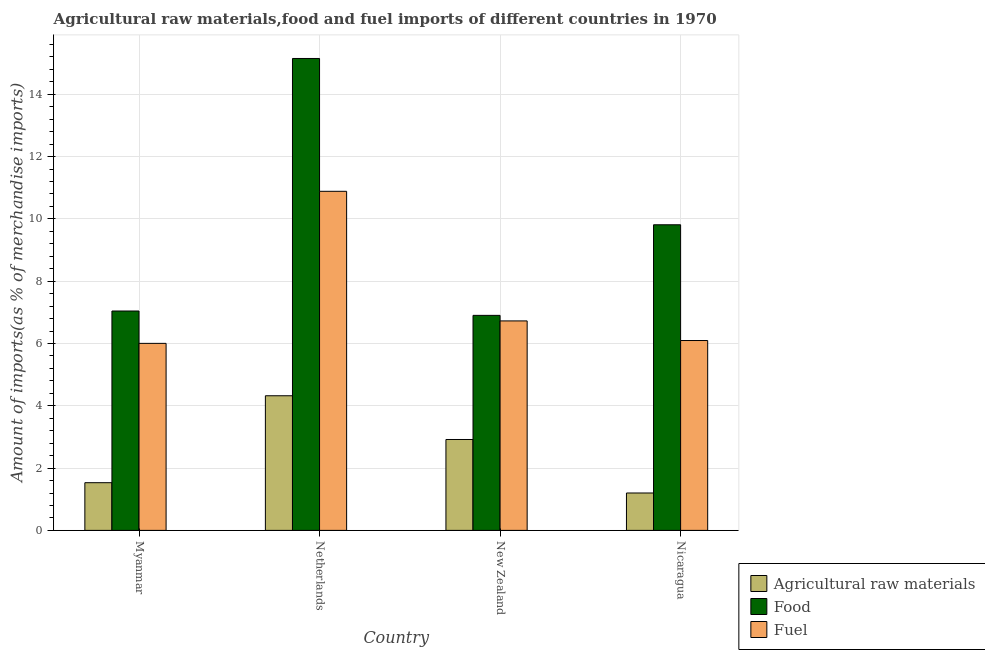How many different coloured bars are there?
Your answer should be compact. 3. How many groups of bars are there?
Offer a terse response. 4. Are the number of bars per tick equal to the number of legend labels?
Your answer should be very brief. Yes. How many bars are there on the 4th tick from the right?
Offer a very short reply. 3. What is the label of the 2nd group of bars from the left?
Offer a very short reply. Netherlands. In how many cases, is the number of bars for a given country not equal to the number of legend labels?
Keep it short and to the point. 0. What is the percentage of raw materials imports in New Zealand?
Provide a succinct answer. 2.92. Across all countries, what is the maximum percentage of raw materials imports?
Offer a terse response. 4.32. Across all countries, what is the minimum percentage of raw materials imports?
Offer a very short reply. 1.2. In which country was the percentage of raw materials imports maximum?
Ensure brevity in your answer.  Netherlands. In which country was the percentage of raw materials imports minimum?
Ensure brevity in your answer.  Nicaragua. What is the total percentage of raw materials imports in the graph?
Your answer should be compact. 9.97. What is the difference between the percentage of raw materials imports in Netherlands and that in Nicaragua?
Provide a short and direct response. 3.12. What is the difference between the percentage of food imports in New Zealand and the percentage of fuel imports in Myanmar?
Make the answer very short. 0.9. What is the average percentage of raw materials imports per country?
Provide a short and direct response. 2.49. What is the difference between the percentage of food imports and percentage of raw materials imports in Nicaragua?
Make the answer very short. 8.61. What is the ratio of the percentage of fuel imports in Netherlands to that in Nicaragua?
Offer a terse response. 1.79. Is the percentage of fuel imports in Netherlands less than that in Nicaragua?
Your response must be concise. No. What is the difference between the highest and the second highest percentage of raw materials imports?
Offer a terse response. 1.4. What is the difference between the highest and the lowest percentage of fuel imports?
Your response must be concise. 4.88. What does the 2nd bar from the left in Myanmar represents?
Offer a terse response. Food. What does the 2nd bar from the right in Nicaragua represents?
Your answer should be very brief. Food. How many bars are there?
Provide a succinct answer. 12. How many countries are there in the graph?
Offer a very short reply. 4. Are the values on the major ticks of Y-axis written in scientific E-notation?
Ensure brevity in your answer.  No. Does the graph contain any zero values?
Ensure brevity in your answer.  No. What is the title of the graph?
Provide a short and direct response. Agricultural raw materials,food and fuel imports of different countries in 1970. What is the label or title of the Y-axis?
Make the answer very short. Amount of imports(as % of merchandise imports). What is the Amount of imports(as % of merchandise imports) of Agricultural raw materials in Myanmar?
Make the answer very short. 1.53. What is the Amount of imports(as % of merchandise imports) in Food in Myanmar?
Ensure brevity in your answer.  7.04. What is the Amount of imports(as % of merchandise imports) of Fuel in Myanmar?
Ensure brevity in your answer.  6. What is the Amount of imports(as % of merchandise imports) in Agricultural raw materials in Netherlands?
Provide a short and direct response. 4.32. What is the Amount of imports(as % of merchandise imports) in Food in Netherlands?
Ensure brevity in your answer.  15.15. What is the Amount of imports(as % of merchandise imports) of Fuel in Netherlands?
Keep it short and to the point. 10.88. What is the Amount of imports(as % of merchandise imports) in Agricultural raw materials in New Zealand?
Give a very brief answer. 2.92. What is the Amount of imports(as % of merchandise imports) of Food in New Zealand?
Make the answer very short. 6.9. What is the Amount of imports(as % of merchandise imports) in Fuel in New Zealand?
Offer a very short reply. 6.72. What is the Amount of imports(as % of merchandise imports) of Agricultural raw materials in Nicaragua?
Give a very brief answer. 1.2. What is the Amount of imports(as % of merchandise imports) in Food in Nicaragua?
Provide a succinct answer. 9.81. What is the Amount of imports(as % of merchandise imports) in Fuel in Nicaragua?
Provide a short and direct response. 6.09. Across all countries, what is the maximum Amount of imports(as % of merchandise imports) of Agricultural raw materials?
Your answer should be very brief. 4.32. Across all countries, what is the maximum Amount of imports(as % of merchandise imports) in Food?
Give a very brief answer. 15.15. Across all countries, what is the maximum Amount of imports(as % of merchandise imports) of Fuel?
Provide a short and direct response. 10.88. Across all countries, what is the minimum Amount of imports(as % of merchandise imports) in Agricultural raw materials?
Offer a terse response. 1.2. Across all countries, what is the minimum Amount of imports(as % of merchandise imports) in Food?
Provide a succinct answer. 6.9. Across all countries, what is the minimum Amount of imports(as % of merchandise imports) of Fuel?
Ensure brevity in your answer.  6. What is the total Amount of imports(as % of merchandise imports) of Agricultural raw materials in the graph?
Provide a short and direct response. 9.97. What is the total Amount of imports(as % of merchandise imports) in Food in the graph?
Provide a succinct answer. 38.91. What is the total Amount of imports(as % of merchandise imports) of Fuel in the graph?
Make the answer very short. 29.71. What is the difference between the Amount of imports(as % of merchandise imports) in Agricultural raw materials in Myanmar and that in Netherlands?
Offer a very short reply. -2.79. What is the difference between the Amount of imports(as % of merchandise imports) in Food in Myanmar and that in Netherlands?
Your answer should be very brief. -8.11. What is the difference between the Amount of imports(as % of merchandise imports) in Fuel in Myanmar and that in Netherlands?
Provide a succinct answer. -4.88. What is the difference between the Amount of imports(as % of merchandise imports) in Agricultural raw materials in Myanmar and that in New Zealand?
Offer a very short reply. -1.39. What is the difference between the Amount of imports(as % of merchandise imports) of Food in Myanmar and that in New Zealand?
Provide a short and direct response. 0.14. What is the difference between the Amount of imports(as % of merchandise imports) of Fuel in Myanmar and that in New Zealand?
Provide a succinct answer. -0.72. What is the difference between the Amount of imports(as % of merchandise imports) in Agricultural raw materials in Myanmar and that in Nicaragua?
Provide a short and direct response. 0.33. What is the difference between the Amount of imports(as % of merchandise imports) of Food in Myanmar and that in Nicaragua?
Ensure brevity in your answer.  -2.77. What is the difference between the Amount of imports(as % of merchandise imports) of Fuel in Myanmar and that in Nicaragua?
Keep it short and to the point. -0.09. What is the difference between the Amount of imports(as % of merchandise imports) of Agricultural raw materials in Netherlands and that in New Zealand?
Provide a succinct answer. 1.4. What is the difference between the Amount of imports(as % of merchandise imports) of Food in Netherlands and that in New Zealand?
Your answer should be very brief. 8.25. What is the difference between the Amount of imports(as % of merchandise imports) of Fuel in Netherlands and that in New Zealand?
Offer a terse response. 4.16. What is the difference between the Amount of imports(as % of merchandise imports) of Agricultural raw materials in Netherlands and that in Nicaragua?
Your answer should be compact. 3.12. What is the difference between the Amount of imports(as % of merchandise imports) in Food in Netherlands and that in Nicaragua?
Your answer should be very brief. 5.34. What is the difference between the Amount of imports(as % of merchandise imports) of Fuel in Netherlands and that in Nicaragua?
Keep it short and to the point. 4.79. What is the difference between the Amount of imports(as % of merchandise imports) in Agricultural raw materials in New Zealand and that in Nicaragua?
Offer a very short reply. 1.72. What is the difference between the Amount of imports(as % of merchandise imports) of Food in New Zealand and that in Nicaragua?
Provide a succinct answer. -2.91. What is the difference between the Amount of imports(as % of merchandise imports) of Fuel in New Zealand and that in Nicaragua?
Make the answer very short. 0.63. What is the difference between the Amount of imports(as % of merchandise imports) of Agricultural raw materials in Myanmar and the Amount of imports(as % of merchandise imports) of Food in Netherlands?
Provide a succinct answer. -13.62. What is the difference between the Amount of imports(as % of merchandise imports) in Agricultural raw materials in Myanmar and the Amount of imports(as % of merchandise imports) in Fuel in Netherlands?
Provide a short and direct response. -9.35. What is the difference between the Amount of imports(as % of merchandise imports) in Food in Myanmar and the Amount of imports(as % of merchandise imports) in Fuel in Netherlands?
Make the answer very short. -3.84. What is the difference between the Amount of imports(as % of merchandise imports) in Agricultural raw materials in Myanmar and the Amount of imports(as % of merchandise imports) in Food in New Zealand?
Provide a succinct answer. -5.37. What is the difference between the Amount of imports(as % of merchandise imports) in Agricultural raw materials in Myanmar and the Amount of imports(as % of merchandise imports) in Fuel in New Zealand?
Ensure brevity in your answer.  -5.19. What is the difference between the Amount of imports(as % of merchandise imports) of Food in Myanmar and the Amount of imports(as % of merchandise imports) of Fuel in New Zealand?
Ensure brevity in your answer.  0.32. What is the difference between the Amount of imports(as % of merchandise imports) of Agricultural raw materials in Myanmar and the Amount of imports(as % of merchandise imports) of Food in Nicaragua?
Give a very brief answer. -8.28. What is the difference between the Amount of imports(as % of merchandise imports) in Agricultural raw materials in Myanmar and the Amount of imports(as % of merchandise imports) in Fuel in Nicaragua?
Your answer should be very brief. -4.56. What is the difference between the Amount of imports(as % of merchandise imports) in Food in Myanmar and the Amount of imports(as % of merchandise imports) in Fuel in Nicaragua?
Your answer should be very brief. 0.95. What is the difference between the Amount of imports(as % of merchandise imports) in Agricultural raw materials in Netherlands and the Amount of imports(as % of merchandise imports) in Food in New Zealand?
Keep it short and to the point. -2.58. What is the difference between the Amount of imports(as % of merchandise imports) of Agricultural raw materials in Netherlands and the Amount of imports(as % of merchandise imports) of Fuel in New Zealand?
Make the answer very short. -2.4. What is the difference between the Amount of imports(as % of merchandise imports) of Food in Netherlands and the Amount of imports(as % of merchandise imports) of Fuel in New Zealand?
Ensure brevity in your answer.  8.42. What is the difference between the Amount of imports(as % of merchandise imports) of Agricultural raw materials in Netherlands and the Amount of imports(as % of merchandise imports) of Food in Nicaragua?
Keep it short and to the point. -5.49. What is the difference between the Amount of imports(as % of merchandise imports) in Agricultural raw materials in Netherlands and the Amount of imports(as % of merchandise imports) in Fuel in Nicaragua?
Keep it short and to the point. -1.77. What is the difference between the Amount of imports(as % of merchandise imports) of Food in Netherlands and the Amount of imports(as % of merchandise imports) of Fuel in Nicaragua?
Make the answer very short. 9.05. What is the difference between the Amount of imports(as % of merchandise imports) in Agricultural raw materials in New Zealand and the Amount of imports(as % of merchandise imports) in Food in Nicaragua?
Ensure brevity in your answer.  -6.89. What is the difference between the Amount of imports(as % of merchandise imports) of Agricultural raw materials in New Zealand and the Amount of imports(as % of merchandise imports) of Fuel in Nicaragua?
Keep it short and to the point. -3.18. What is the difference between the Amount of imports(as % of merchandise imports) in Food in New Zealand and the Amount of imports(as % of merchandise imports) in Fuel in Nicaragua?
Your response must be concise. 0.81. What is the average Amount of imports(as % of merchandise imports) in Agricultural raw materials per country?
Make the answer very short. 2.49. What is the average Amount of imports(as % of merchandise imports) of Food per country?
Make the answer very short. 9.73. What is the average Amount of imports(as % of merchandise imports) of Fuel per country?
Make the answer very short. 7.43. What is the difference between the Amount of imports(as % of merchandise imports) in Agricultural raw materials and Amount of imports(as % of merchandise imports) in Food in Myanmar?
Give a very brief answer. -5.51. What is the difference between the Amount of imports(as % of merchandise imports) of Agricultural raw materials and Amount of imports(as % of merchandise imports) of Fuel in Myanmar?
Your response must be concise. -4.47. What is the difference between the Amount of imports(as % of merchandise imports) in Food and Amount of imports(as % of merchandise imports) in Fuel in Myanmar?
Your response must be concise. 1.04. What is the difference between the Amount of imports(as % of merchandise imports) in Agricultural raw materials and Amount of imports(as % of merchandise imports) in Food in Netherlands?
Provide a short and direct response. -10.83. What is the difference between the Amount of imports(as % of merchandise imports) in Agricultural raw materials and Amount of imports(as % of merchandise imports) in Fuel in Netherlands?
Your answer should be compact. -6.56. What is the difference between the Amount of imports(as % of merchandise imports) of Food and Amount of imports(as % of merchandise imports) of Fuel in Netherlands?
Ensure brevity in your answer.  4.26. What is the difference between the Amount of imports(as % of merchandise imports) in Agricultural raw materials and Amount of imports(as % of merchandise imports) in Food in New Zealand?
Offer a terse response. -3.98. What is the difference between the Amount of imports(as % of merchandise imports) in Agricultural raw materials and Amount of imports(as % of merchandise imports) in Fuel in New Zealand?
Make the answer very short. -3.81. What is the difference between the Amount of imports(as % of merchandise imports) in Food and Amount of imports(as % of merchandise imports) in Fuel in New Zealand?
Your response must be concise. 0.18. What is the difference between the Amount of imports(as % of merchandise imports) of Agricultural raw materials and Amount of imports(as % of merchandise imports) of Food in Nicaragua?
Provide a short and direct response. -8.61. What is the difference between the Amount of imports(as % of merchandise imports) in Agricultural raw materials and Amount of imports(as % of merchandise imports) in Fuel in Nicaragua?
Offer a terse response. -4.89. What is the difference between the Amount of imports(as % of merchandise imports) of Food and Amount of imports(as % of merchandise imports) of Fuel in Nicaragua?
Keep it short and to the point. 3.72. What is the ratio of the Amount of imports(as % of merchandise imports) of Agricultural raw materials in Myanmar to that in Netherlands?
Your response must be concise. 0.35. What is the ratio of the Amount of imports(as % of merchandise imports) of Food in Myanmar to that in Netherlands?
Your response must be concise. 0.46. What is the ratio of the Amount of imports(as % of merchandise imports) of Fuel in Myanmar to that in Netherlands?
Provide a short and direct response. 0.55. What is the ratio of the Amount of imports(as % of merchandise imports) in Agricultural raw materials in Myanmar to that in New Zealand?
Offer a terse response. 0.52. What is the ratio of the Amount of imports(as % of merchandise imports) in Food in Myanmar to that in New Zealand?
Your answer should be very brief. 1.02. What is the ratio of the Amount of imports(as % of merchandise imports) in Fuel in Myanmar to that in New Zealand?
Ensure brevity in your answer.  0.89. What is the ratio of the Amount of imports(as % of merchandise imports) in Agricultural raw materials in Myanmar to that in Nicaragua?
Your answer should be compact. 1.28. What is the ratio of the Amount of imports(as % of merchandise imports) of Food in Myanmar to that in Nicaragua?
Provide a short and direct response. 0.72. What is the ratio of the Amount of imports(as % of merchandise imports) of Fuel in Myanmar to that in Nicaragua?
Your answer should be very brief. 0.99. What is the ratio of the Amount of imports(as % of merchandise imports) of Agricultural raw materials in Netherlands to that in New Zealand?
Offer a very short reply. 1.48. What is the ratio of the Amount of imports(as % of merchandise imports) of Food in Netherlands to that in New Zealand?
Your response must be concise. 2.19. What is the ratio of the Amount of imports(as % of merchandise imports) of Fuel in Netherlands to that in New Zealand?
Provide a short and direct response. 1.62. What is the ratio of the Amount of imports(as % of merchandise imports) of Agricultural raw materials in Netherlands to that in Nicaragua?
Provide a succinct answer. 3.6. What is the ratio of the Amount of imports(as % of merchandise imports) in Food in Netherlands to that in Nicaragua?
Your answer should be compact. 1.54. What is the ratio of the Amount of imports(as % of merchandise imports) in Fuel in Netherlands to that in Nicaragua?
Your answer should be compact. 1.79. What is the ratio of the Amount of imports(as % of merchandise imports) of Agricultural raw materials in New Zealand to that in Nicaragua?
Make the answer very short. 2.43. What is the ratio of the Amount of imports(as % of merchandise imports) in Food in New Zealand to that in Nicaragua?
Make the answer very short. 0.7. What is the ratio of the Amount of imports(as % of merchandise imports) in Fuel in New Zealand to that in Nicaragua?
Your answer should be very brief. 1.1. What is the difference between the highest and the second highest Amount of imports(as % of merchandise imports) in Agricultural raw materials?
Offer a terse response. 1.4. What is the difference between the highest and the second highest Amount of imports(as % of merchandise imports) in Food?
Offer a terse response. 5.34. What is the difference between the highest and the second highest Amount of imports(as % of merchandise imports) of Fuel?
Give a very brief answer. 4.16. What is the difference between the highest and the lowest Amount of imports(as % of merchandise imports) in Agricultural raw materials?
Provide a short and direct response. 3.12. What is the difference between the highest and the lowest Amount of imports(as % of merchandise imports) in Food?
Ensure brevity in your answer.  8.25. What is the difference between the highest and the lowest Amount of imports(as % of merchandise imports) in Fuel?
Your answer should be compact. 4.88. 